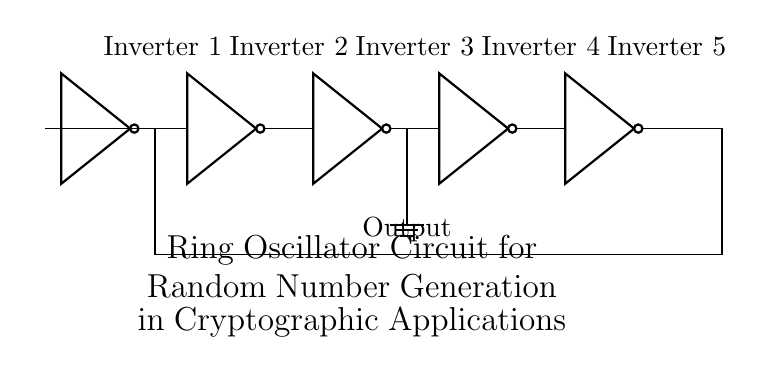What components are in the circuit? The circuit consists of five inverters connected in a loop to form a ring oscillator. Each inverter is represented by its symbol, which is a triangle with a small circle at the output.
Answer: Five inverters What is the function of this circuit? The primary function of the ring oscillator is to produce a periodic output signal, which can be utilized for random number generation in cryptographic applications. The inverters create a feedback loop that generates oscillations.
Answer: Generate oscillations How many inverters are in the feedback loop? The feedback loop of the ring oscillator circuit contains five inverters connected sequentially in a loop where the output of the last inverter feeds back to the first inverter's input.
Answer: Five What is the output node of the circuit? The output node is connected to the output of the third inverter, which is denoted in the diagram. This output provides the oscillating signal that can be used for further applications.
Answer: Third inverter What is the significance of the feedback connection? The feedback connection is crucial in a ring oscillator, as it creates a condition for sustained oscillation. Without this feedback, the circuit would not be able to continuously generate the oscillating output necessary for random number generation.
Answer: Sustained oscillation How does the number of inverters affect the oscillation frequency? The number of inverters in a ring oscillator directly influences the oscillation frequency; more inverters typically result in a lower frequency due to increased propagation delay, while fewer inverters can produce a higher frequency signal.
Answer: Affects frequency What role do inverters play in this circuit? In this circuit, the inverters serve as amplifiers that invert the input signal while introducing propagation delays, which are essential for establishing the timing of the oscillation and generating the required random output signal.
Answer: Invert and delay 